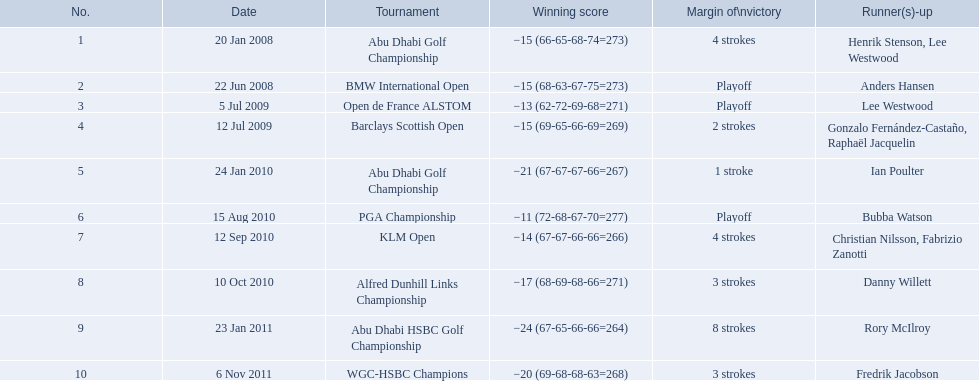What was the total number of strokes martin kaymer had at the klm open? 4 strokes. How many strokes were taken during the abu dhabi golf championship? 4 strokes. How many more strokes occurred at the klm than at the barclays open? 2 strokes. Give me the full table as a dictionary. {'header': ['No.', 'Date', 'Tournament', 'Winning score', 'Margin of\\nvictory', 'Runner(s)-up'], 'rows': [['1', '20 Jan 2008', 'Abu Dhabi Golf Championship', '−15 (66-65-68-74=273)', '4 strokes', 'Henrik Stenson, Lee Westwood'], ['2', '22 Jun 2008', 'BMW International Open', '−15 (68-63-67-75=273)', 'Playoff', 'Anders Hansen'], ['3', '5 Jul 2009', 'Open de France ALSTOM', '−13 (62-72-69-68=271)', 'Playoff', 'Lee Westwood'], ['4', '12 Jul 2009', 'Barclays Scottish Open', '−15 (69-65-66-69=269)', '2 strokes', 'Gonzalo Fernández-Castaño, Raphaël Jacquelin'], ['5', '24 Jan 2010', 'Abu Dhabi Golf Championship', '−21 (67-67-67-66=267)', '1 stroke', 'Ian Poulter'], ['6', '15 Aug 2010', 'PGA Championship', '−11 (72-68-67-70=277)', 'Playoff', 'Bubba Watson'], ['7', '12 Sep 2010', 'KLM Open', '−14 (67-67-66-66=266)', '4 strokes', 'Christian Nilsson, Fabrizio Zanotti'], ['8', '10 Oct 2010', 'Alfred Dunhill Links Championship', '−17 (68-69-68-66=271)', '3 strokes', 'Danny Willett'], ['9', '23 Jan 2011', 'Abu Dhabi HSBC Golf Championship', '−24 (67-65-66-66=264)', '8 strokes', 'Rory McIlroy'], ['10', '6 Nov 2011', 'WGC-HSBC Champions', '−20 (69-68-68-63=268)', '3 strokes', 'Fredrik Jacobson']]} 